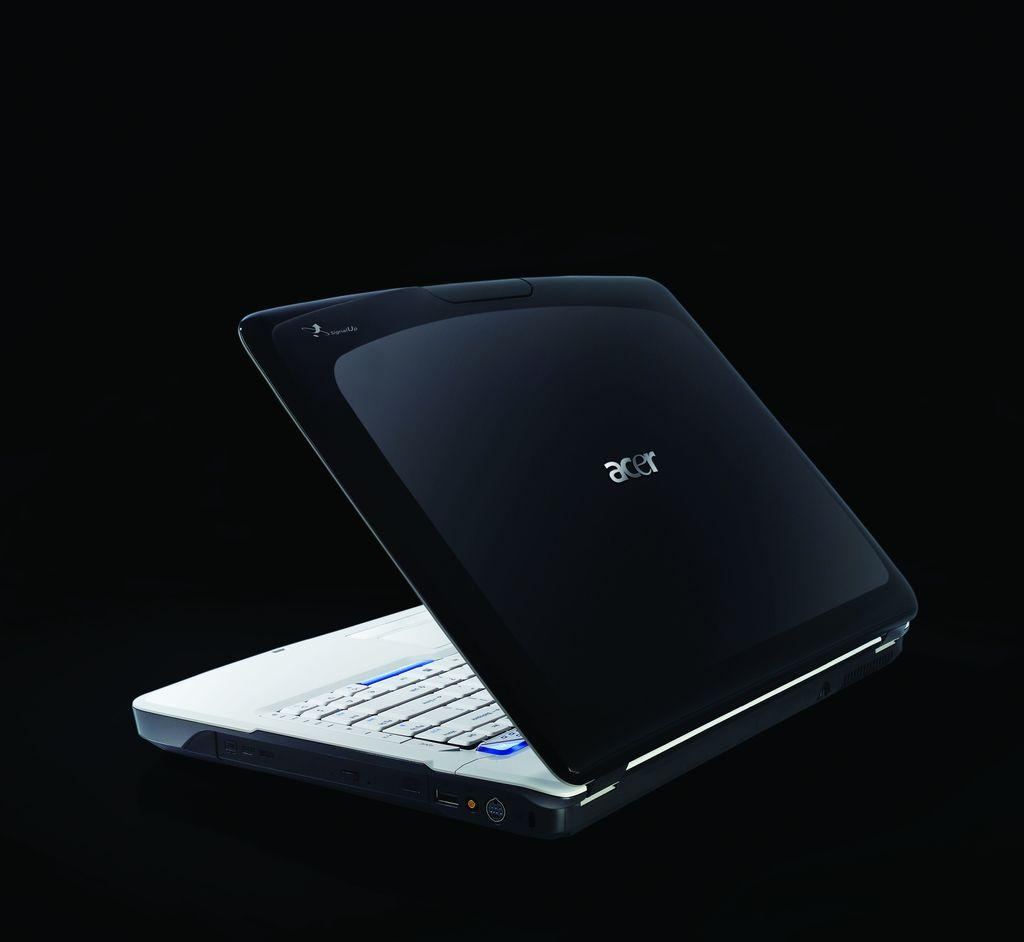What electronic device is visible in the image? There is a laptop in the image. What can be inferred about the lighting conditions in the image? The background of the image is dark, suggesting that the lighting is low or dim. What mathematical operation is being performed on the laptop in the image? There is no indication of any mathematical operation being performed on the laptop in the image. 